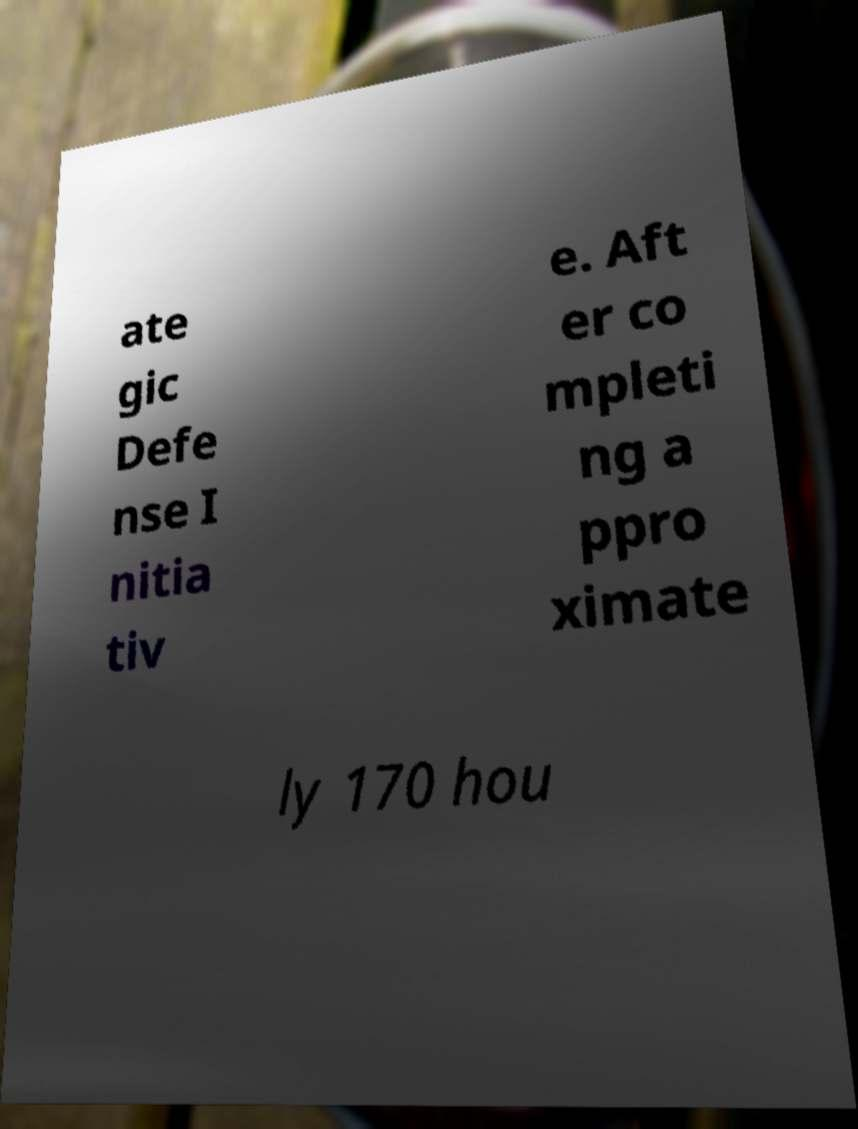For documentation purposes, I need the text within this image transcribed. Could you provide that? ate gic Defe nse I nitia tiv e. Aft er co mpleti ng a ppro ximate ly 170 hou 